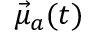<formula> <loc_0><loc_0><loc_500><loc_500>\vec { \mu } _ { a } ( t )</formula> 